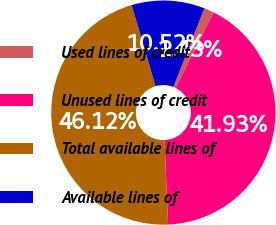<chart> <loc_0><loc_0><loc_500><loc_500><pie_chart><fcel>Used lines of credit<fcel>Unused lines of credit<fcel>Total available lines of<fcel>Available lines of<nl><fcel>1.43%<fcel>41.93%<fcel>46.12%<fcel>10.52%<nl></chart> 